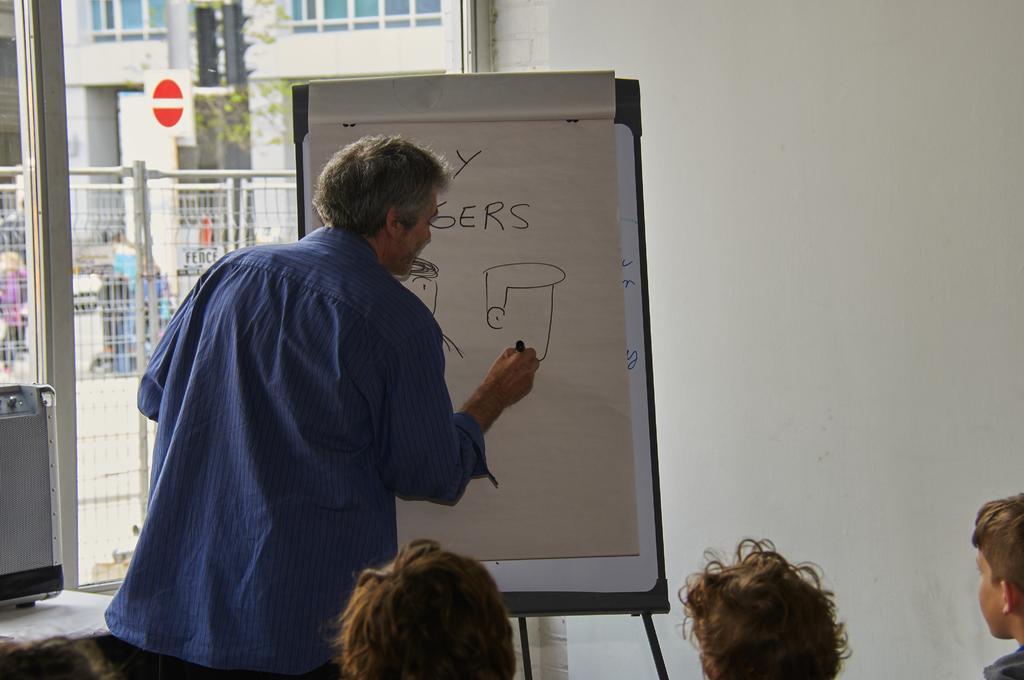Could you give a brief overview of what you see in this image? A man is standing and writing on the board. He wore a blue color shirt. On the left side there is a glass wall, outside this there is an iron gate. 